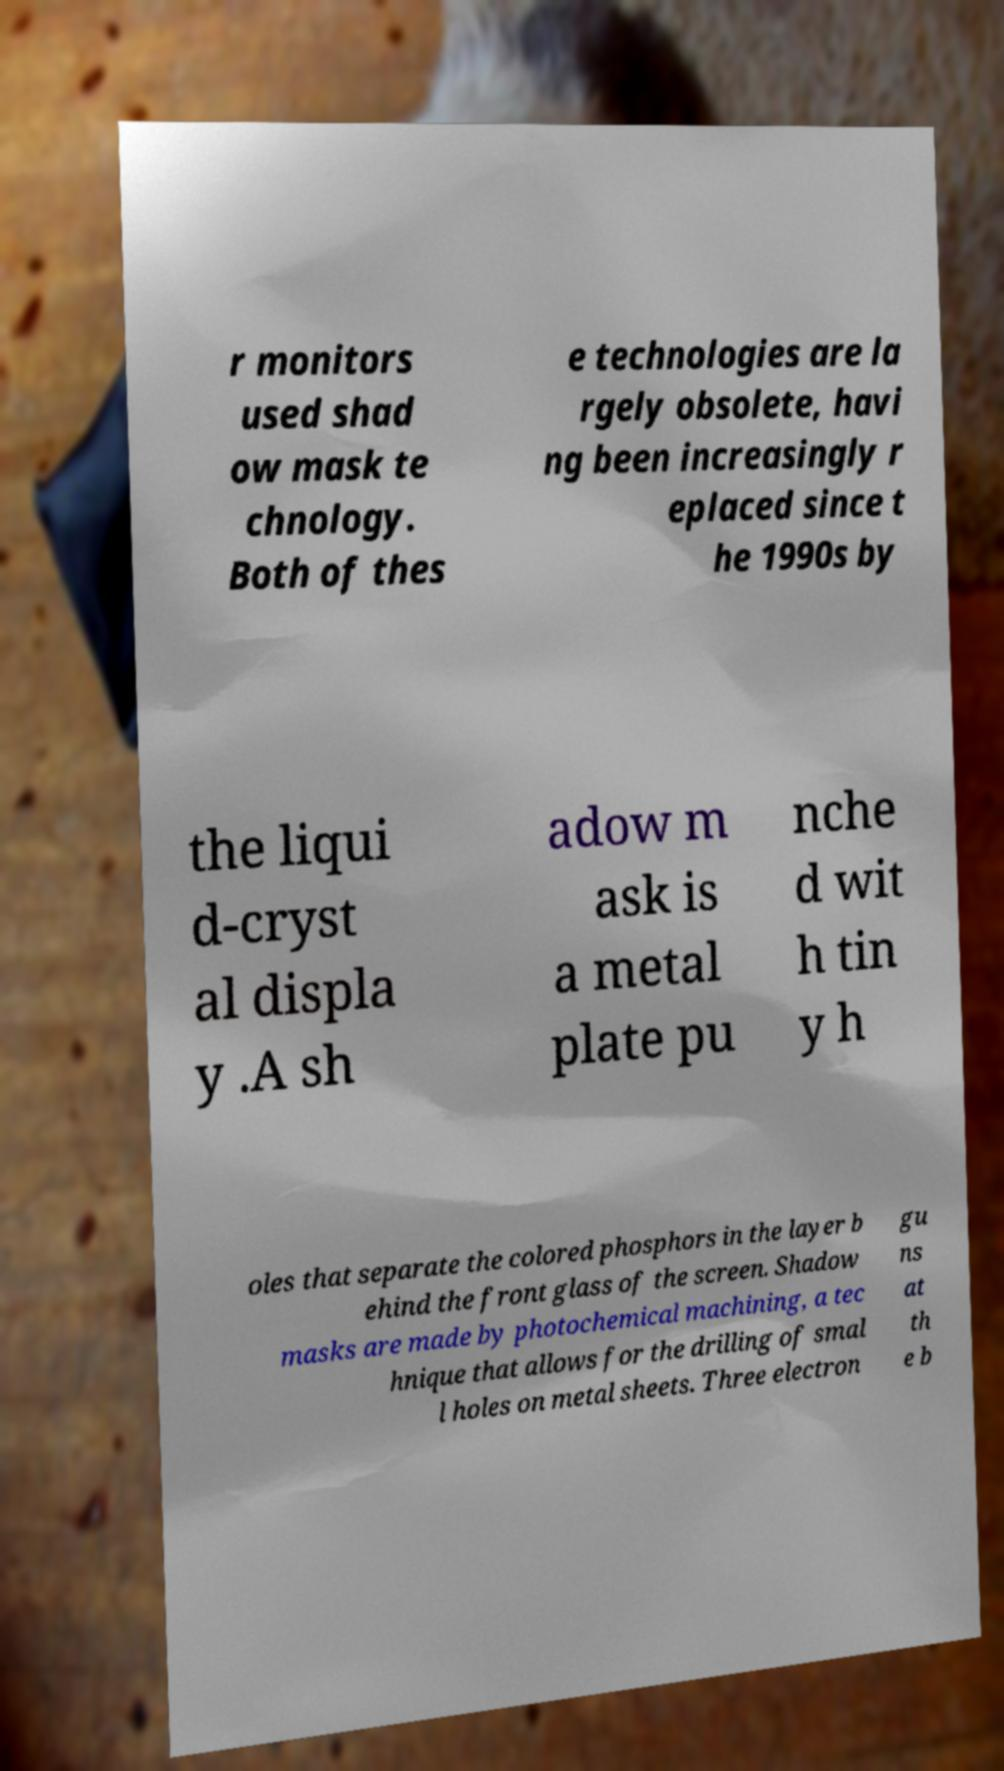Could you extract and type out the text from this image? r monitors used shad ow mask te chnology. Both of thes e technologies are la rgely obsolete, havi ng been increasingly r eplaced since t he 1990s by the liqui d-cryst al displa y .A sh adow m ask is a metal plate pu nche d wit h tin y h oles that separate the colored phosphors in the layer b ehind the front glass of the screen. Shadow masks are made by photochemical machining, a tec hnique that allows for the drilling of smal l holes on metal sheets. Three electron gu ns at th e b 